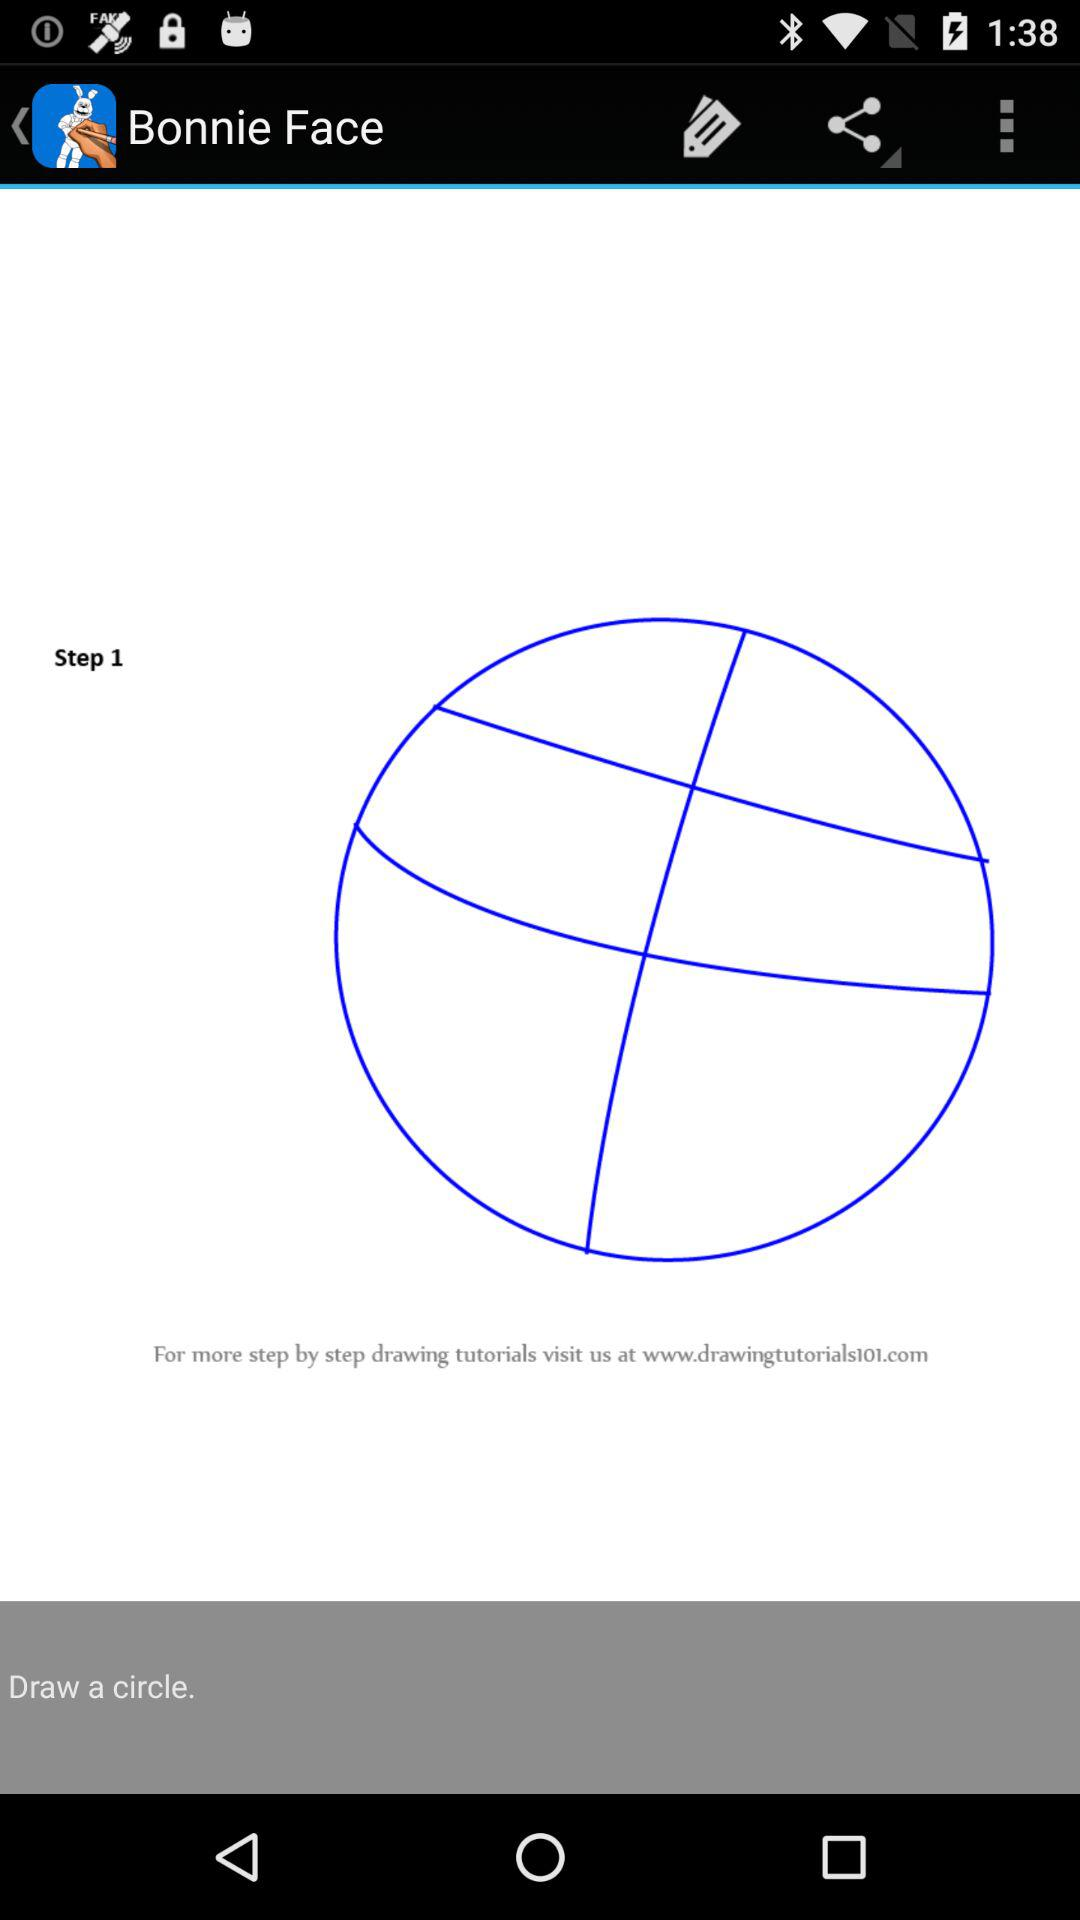What's the name of the website for more step by step drawing tutorials? The name of the website is www.drawingtutorials101.com. 